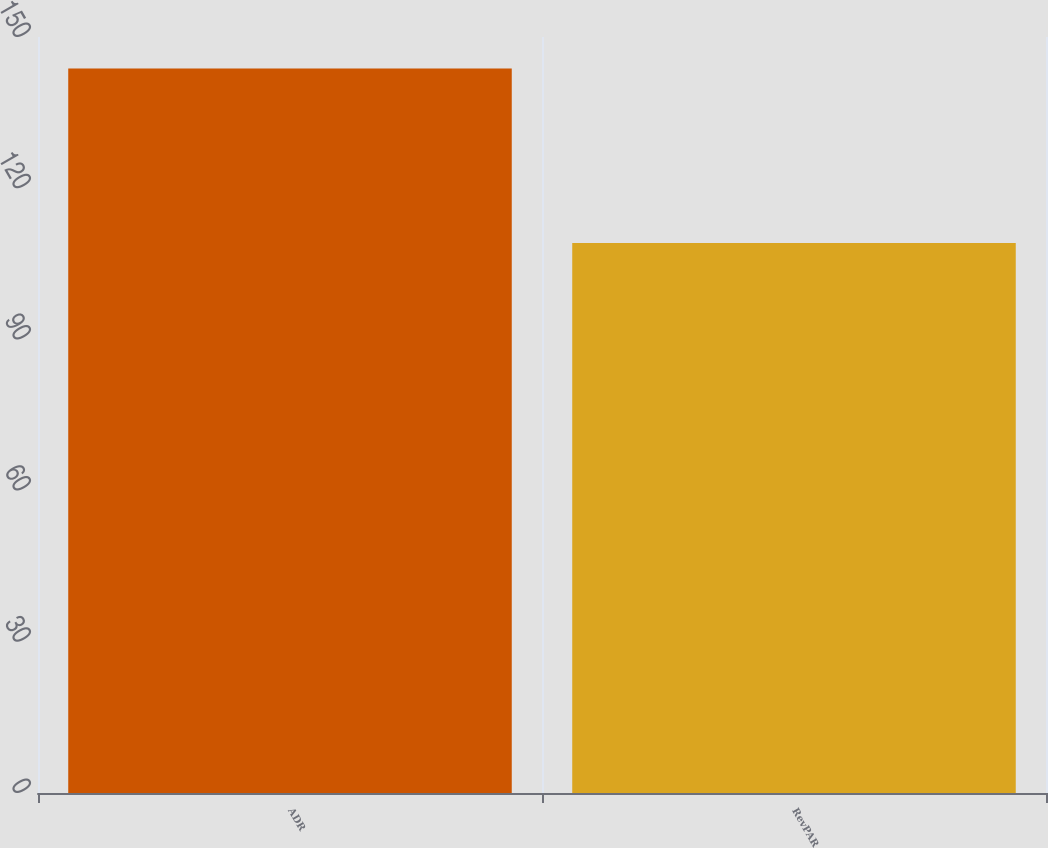Convert chart. <chart><loc_0><loc_0><loc_500><loc_500><bar_chart><fcel>ADR<fcel>RevPAR<nl><fcel>143.75<fcel>109.14<nl></chart> 